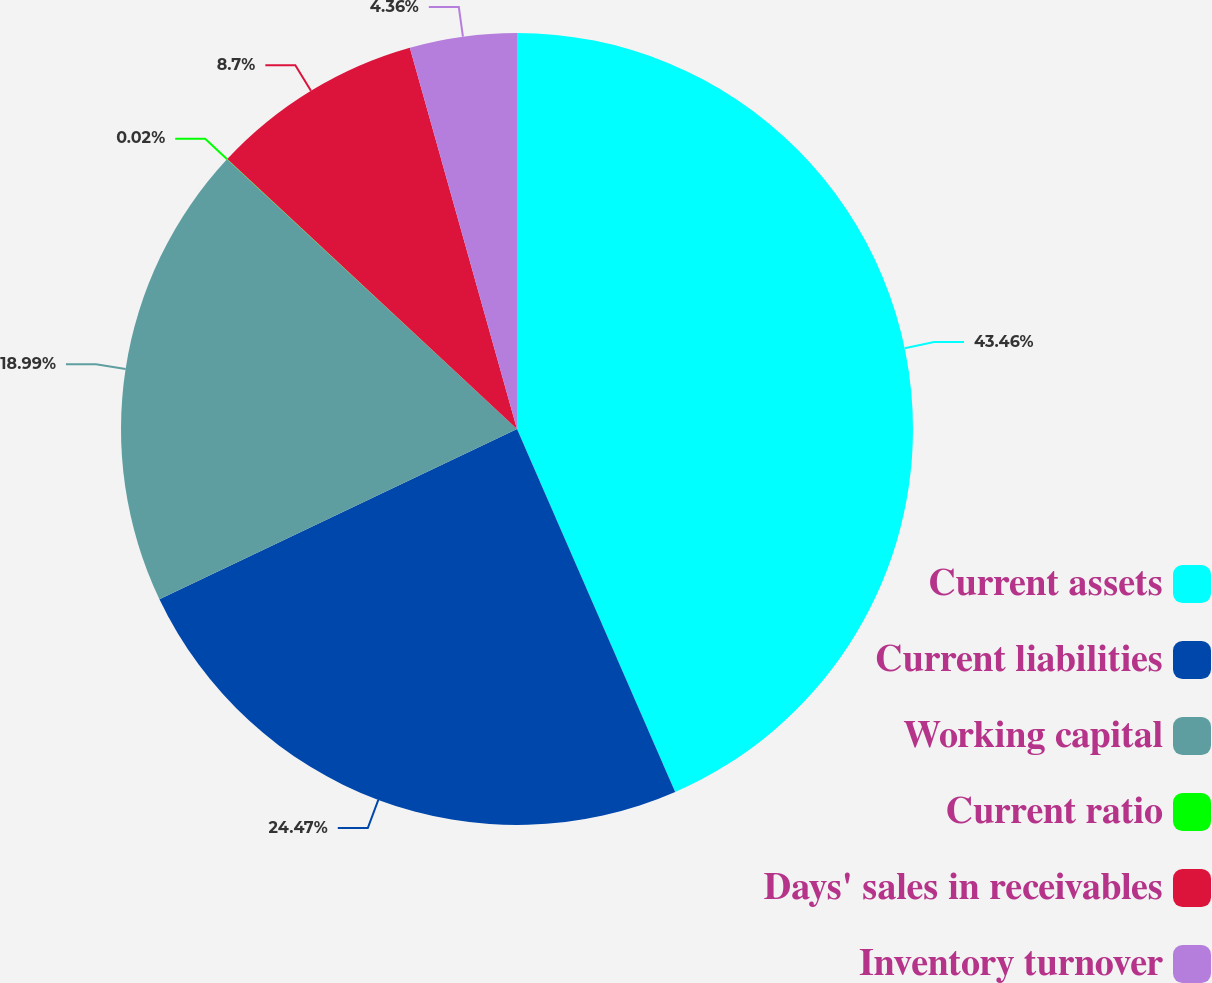<chart> <loc_0><loc_0><loc_500><loc_500><pie_chart><fcel>Current assets<fcel>Current liabilities<fcel>Working capital<fcel>Current ratio<fcel>Days' sales in receivables<fcel>Inventory turnover<nl><fcel>43.46%<fcel>24.47%<fcel>18.99%<fcel>0.02%<fcel>8.7%<fcel>4.36%<nl></chart> 